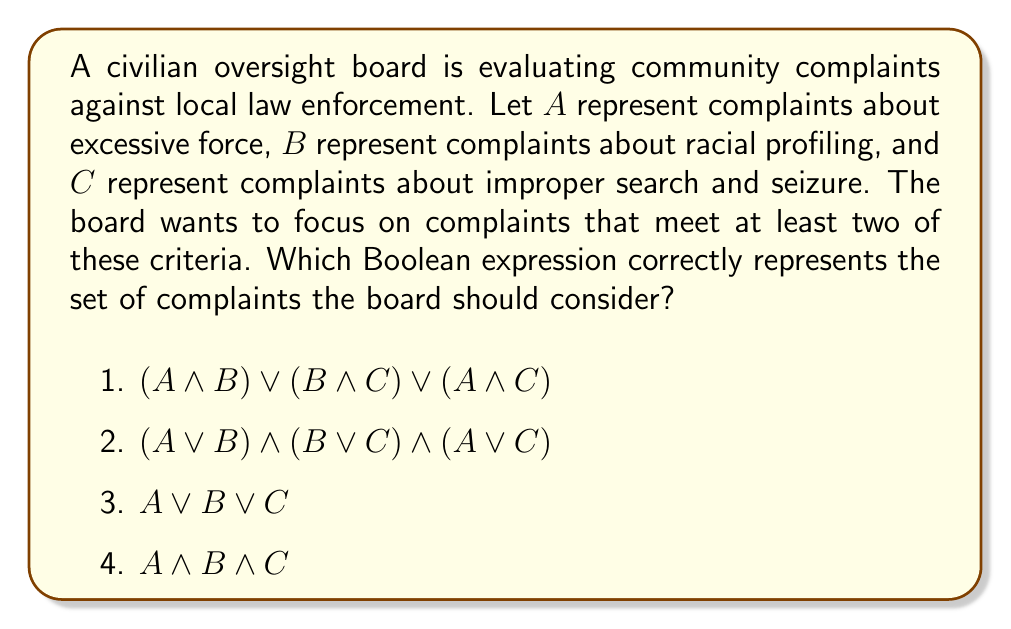Help me with this question. To solve this problem, we need to understand what each expression represents and which one matches the board's criteria:

1) $(A \land B) \lor (B \land C) \lor (A \land C)$
   This expression represents complaints that are:
   (excessive force AND racial profiling) OR
   (racial profiling AND improper search and seizure) OR
   (excessive force AND improper search and seizure)
   
   This correctly captures complaints that meet at least two criteria.

2) $(A \lor B) \land (B \lor C) \land (A \lor C)$
   This expression would include complaints that have at least one element from each pair of criteria, but doesn't necessarily ensure at least two criteria are met for each complaint.

3) $A \lor B \lor C$
   This expression represents complaints that meet at least one of the criteria, which is too broad for the board's focus.

4) $A \land B \land C$
   This expression represents complaints that meet all three criteria, which is too restrictive for the board's focus.

Therefore, the correct expression is option 1: $(A \land B) \lor (B \land C) \lor (A \land C)$
Answer: $(A \land B) \lor (B \land C) \lor (A \land C)$ 